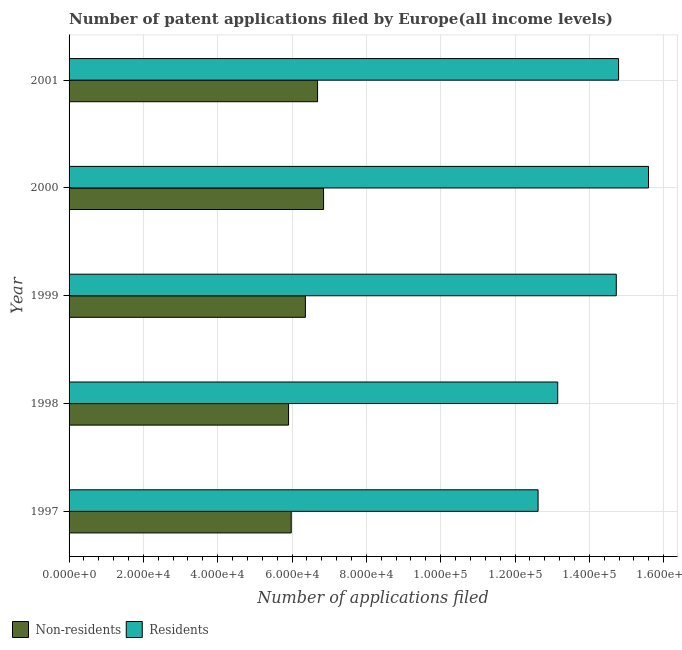How many groups of bars are there?
Offer a terse response. 5. How many bars are there on the 4th tick from the top?
Offer a very short reply. 2. What is the label of the 1st group of bars from the top?
Ensure brevity in your answer.  2001. In how many cases, is the number of bars for a given year not equal to the number of legend labels?
Provide a short and direct response. 0. What is the number of patent applications by non residents in 2001?
Provide a succinct answer. 6.69e+04. Across all years, what is the maximum number of patent applications by non residents?
Keep it short and to the point. 6.85e+04. Across all years, what is the minimum number of patent applications by residents?
Your answer should be compact. 1.26e+05. What is the total number of patent applications by residents in the graph?
Provide a succinct answer. 7.09e+05. What is the difference between the number of patent applications by residents in 1999 and that in 2001?
Keep it short and to the point. -616. What is the difference between the number of patent applications by residents in 1998 and the number of patent applications by non residents in 2001?
Give a very brief answer. 6.46e+04. What is the average number of patent applications by residents per year?
Your response must be concise. 1.42e+05. In the year 1997, what is the difference between the number of patent applications by residents and number of patent applications by non residents?
Make the answer very short. 6.64e+04. In how many years, is the number of patent applications by residents greater than 136000 ?
Keep it short and to the point. 3. Is the number of patent applications by non residents in 1998 less than that in 2001?
Your response must be concise. Yes. Is the difference between the number of patent applications by non residents in 1999 and 2001 greater than the difference between the number of patent applications by residents in 1999 and 2001?
Offer a very short reply. No. What is the difference between the highest and the second highest number of patent applications by residents?
Keep it short and to the point. 8061. What is the difference between the highest and the lowest number of patent applications by non residents?
Provide a succinct answer. 9422. In how many years, is the number of patent applications by non residents greater than the average number of patent applications by non residents taken over all years?
Give a very brief answer. 3. What does the 1st bar from the top in 1997 represents?
Offer a terse response. Residents. What does the 1st bar from the bottom in 1999 represents?
Ensure brevity in your answer.  Non-residents. How many bars are there?
Offer a very short reply. 10. Are all the bars in the graph horizontal?
Your answer should be very brief. Yes. How many years are there in the graph?
Your response must be concise. 5. What is the difference between two consecutive major ticks on the X-axis?
Offer a very short reply. 2.00e+04. Are the values on the major ticks of X-axis written in scientific E-notation?
Offer a terse response. Yes. How are the legend labels stacked?
Keep it short and to the point. Horizontal. What is the title of the graph?
Your answer should be compact. Number of patent applications filed by Europe(all income levels). Does "current US$" appear as one of the legend labels in the graph?
Provide a succinct answer. No. What is the label or title of the X-axis?
Your answer should be very brief. Number of applications filed. What is the label or title of the Y-axis?
Your response must be concise. Year. What is the Number of applications filed of Non-residents in 1997?
Your response must be concise. 5.98e+04. What is the Number of applications filed of Residents in 1997?
Keep it short and to the point. 1.26e+05. What is the Number of applications filed of Non-residents in 1998?
Provide a succinct answer. 5.91e+04. What is the Number of applications filed of Residents in 1998?
Offer a very short reply. 1.31e+05. What is the Number of applications filed of Non-residents in 1999?
Provide a succinct answer. 6.36e+04. What is the Number of applications filed of Residents in 1999?
Ensure brevity in your answer.  1.47e+05. What is the Number of applications filed in Non-residents in 2000?
Offer a terse response. 6.85e+04. What is the Number of applications filed in Residents in 2000?
Ensure brevity in your answer.  1.56e+05. What is the Number of applications filed in Non-residents in 2001?
Your answer should be very brief. 6.69e+04. What is the Number of applications filed of Residents in 2001?
Give a very brief answer. 1.48e+05. Across all years, what is the maximum Number of applications filed in Non-residents?
Offer a terse response. 6.85e+04. Across all years, what is the maximum Number of applications filed in Residents?
Provide a short and direct response. 1.56e+05. Across all years, what is the minimum Number of applications filed of Non-residents?
Offer a very short reply. 5.91e+04. Across all years, what is the minimum Number of applications filed of Residents?
Your response must be concise. 1.26e+05. What is the total Number of applications filed in Non-residents in the graph?
Make the answer very short. 3.18e+05. What is the total Number of applications filed in Residents in the graph?
Your response must be concise. 7.09e+05. What is the difference between the Number of applications filed of Non-residents in 1997 and that in 1998?
Provide a short and direct response. 711. What is the difference between the Number of applications filed of Residents in 1997 and that in 1998?
Your answer should be very brief. -5285. What is the difference between the Number of applications filed in Non-residents in 1997 and that in 1999?
Your answer should be very brief. -3816. What is the difference between the Number of applications filed of Residents in 1997 and that in 1999?
Ensure brevity in your answer.  -2.10e+04. What is the difference between the Number of applications filed in Non-residents in 1997 and that in 2000?
Offer a very short reply. -8711. What is the difference between the Number of applications filed of Residents in 1997 and that in 2000?
Keep it short and to the point. -2.97e+04. What is the difference between the Number of applications filed in Non-residents in 1997 and that in 2001?
Give a very brief answer. -7092. What is the difference between the Number of applications filed in Residents in 1997 and that in 2001?
Provide a short and direct response. -2.17e+04. What is the difference between the Number of applications filed in Non-residents in 1998 and that in 1999?
Your response must be concise. -4527. What is the difference between the Number of applications filed in Residents in 1998 and that in 1999?
Offer a terse response. -1.58e+04. What is the difference between the Number of applications filed of Non-residents in 1998 and that in 2000?
Offer a terse response. -9422. What is the difference between the Number of applications filed in Residents in 1998 and that in 2000?
Offer a terse response. -2.44e+04. What is the difference between the Number of applications filed of Non-residents in 1998 and that in 2001?
Provide a short and direct response. -7803. What is the difference between the Number of applications filed of Residents in 1998 and that in 2001?
Provide a succinct answer. -1.64e+04. What is the difference between the Number of applications filed of Non-residents in 1999 and that in 2000?
Provide a succinct answer. -4895. What is the difference between the Number of applications filed in Residents in 1999 and that in 2000?
Keep it short and to the point. -8677. What is the difference between the Number of applications filed in Non-residents in 1999 and that in 2001?
Offer a terse response. -3276. What is the difference between the Number of applications filed of Residents in 1999 and that in 2001?
Provide a succinct answer. -616. What is the difference between the Number of applications filed in Non-residents in 2000 and that in 2001?
Your response must be concise. 1619. What is the difference between the Number of applications filed of Residents in 2000 and that in 2001?
Your response must be concise. 8061. What is the difference between the Number of applications filed of Non-residents in 1997 and the Number of applications filed of Residents in 1998?
Provide a succinct answer. -7.17e+04. What is the difference between the Number of applications filed of Non-residents in 1997 and the Number of applications filed of Residents in 1999?
Offer a terse response. -8.75e+04. What is the difference between the Number of applications filed of Non-residents in 1997 and the Number of applications filed of Residents in 2000?
Make the answer very short. -9.62e+04. What is the difference between the Number of applications filed of Non-residents in 1997 and the Number of applications filed of Residents in 2001?
Offer a very short reply. -8.81e+04. What is the difference between the Number of applications filed of Non-residents in 1998 and the Number of applications filed of Residents in 1999?
Offer a very short reply. -8.82e+04. What is the difference between the Number of applications filed in Non-residents in 1998 and the Number of applications filed in Residents in 2000?
Your answer should be very brief. -9.69e+04. What is the difference between the Number of applications filed of Non-residents in 1998 and the Number of applications filed of Residents in 2001?
Ensure brevity in your answer.  -8.88e+04. What is the difference between the Number of applications filed of Non-residents in 1999 and the Number of applications filed of Residents in 2000?
Ensure brevity in your answer.  -9.23e+04. What is the difference between the Number of applications filed of Non-residents in 1999 and the Number of applications filed of Residents in 2001?
Make the answer very short. -8.43e+04. What is the difference between the Number of applications filed in Non-residents in 2000 and the Number of applications filed in Residents in 2001?
Provide a succinct answer. -7.94e+04. What is the average Number of applications filed in Non-residents per year?
Ensure brevity in your answer.  6.36e+04. What is the average Number of applications filed of Residents per year?
Your answer should be very brief. 1.42e+05. In the year 1997, what is the difference between the Number of applications filed in Non-residents and Number of applications filed in Residents?
Your response must be concise. -6.64e+04. In the year 1998, what is the difference between the Number of applications filed in Non-residents and Number of applications filed in Residents?
Give a very brief answer. -7.24e+04. In the year 1999, what is the difference between the Number of applications filed of Non-residents and Number of applications filed of Residents?
Ensure brevity in your answer.  -8.37e+04. In the year 2000, what is the difference between the Number of applications filed in Non-residents and Number of applications filed in Residents?
Keep it short and to the point. -8.74e+04. In the year 2001, what is the difference between the Number of applications filed of Non-residents and Number of applications filed of Residents?
Provide a succinct answer. -8.10e+04. What is the ratio of the Number of applications filed in Non-residents in 1997 to that in 1998?
Provide a succinct answer. 1.01. What is the ratio of the Number of applications filed of Residents in 1997 to that in 1998?
Your answer should be very brief. 0.96. What is the ratio of the Number of applications filed of Non-residents in 1997 to that in 2000?
Offer a terse response. 0.87. What is the ratio of the Number of applications filed of Residents in 1997 to that in 2000?
Your response must be concise. 0.81. What is the ratio of the Number of applications filed of Non-residents in 1997 to that in 2001?
Make the answer very short. 0.89. What is the ratio of the Number of applications filed in Residents in 1997 to that in 2001?
Your response must be concise. 0.85. What is the ratio of the Number of applications filed in Non-residents in 1998 to that in 1999?
Your answer should be compact. 0.93. What is the ratio of the Number of applications filed of Residents in 1998 to that in 1999?
Make the answer very short. 0.89. What is the ratio of the Number of applications filed of Non-residents in 1998 to that in 2000?
Provide a succinct answer. 0.86. What is the ratio of the Number of applications filed in Residents in 1998 to that in 2000?
Your answer should be compact. 0.84. What is the ratio of the Number of applications filed of Non-residents in 1998 to that in 2001?
Your answer should be very brief. 0.88. What is the ratio of the Number of applications filed of Residents in 1998 to that in 2001?
Provide a short and direct response. 0.89. What is the ratio of the Number of applications filed of Non-residents in 1999 to that in 2000?
Offer a very short reply. 0.93. What is the ratio of the Number of applications filed in Residents in 1999 to that in 2000?
Provide a short and direct response. 0.94. What is the ratio of the Number of applications filed in Non-residents in 1999 to that in 2001?
Offer a very short reply. 0.95. What is the ratio of the Number of applications filed in Non-residents in 2000 to that in 2001?
Make the answer very short. 1.02. What is the ratio of the Number of applications filed of Residents in 2000 to that in 2001?
Your answer should be compact. 1.05. What is the difference between the highest and the second highest Number of applications filed in Non-residents?
Your answer should be very brief. 1619. What is the difference between the highest and the second highest Number of applications filed of Residents?
Your answer should be compact. 8061. What is the difference between the highest and the lowest Number of applications filed of Non-residents?
Your answer should be very brief. 9422. What is the difference between the highest and the lowest Number of applications filed in Residents?
Offer a very short reply. 2.97e+04. 